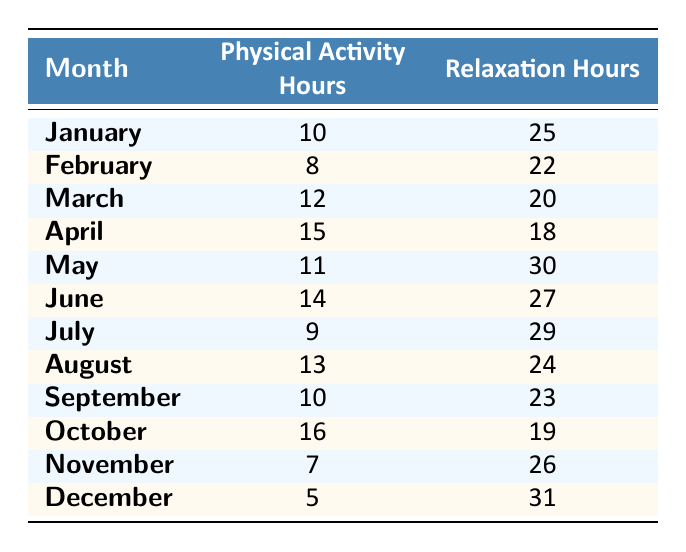What month had the highest physical activity hours? By examining the Physical Activity Hours column, April shows the highest value with 15 hours.
Answer: April What month had the lowest relaxation hours? Looking at the Relaxation Hours column, December has the lowest value with 31 hours.
Answer: December What is the total number of physical activity hours tracked in the first half of the year (January to June)? Summing the first six months: 10 (Jan) + 8 (Feb) + 12 (Mar) + 15 (Apr) + 11 (May) + 14 (Jun) = 70 hours.
Answer: 70 Was there more relaxation time than physical activity time in March? In March, there were 12 Physical Activity Hours and 20 Relaxation Hours, indicating relaxation hours exceeded physical activity hours.
Answer: Yes What is the average number of relaxation hours per month over the year? Adding all the Relaxation Hours: 25 + 22 + 20 + 18 + 30 + 27 + 29 + 24 + 23 + 19 + 26 + 31 =  24.5 and dividing by 12 (months) gives the average of 24.5 hours per month.
Answer: 24.5 Which month saw a significant drop in physical activity hours compared to the previous month? By looking at the differences, November has a significant drop with only 7 hours compared to 16 in October (a difference of 9 hours).
Answer: November How many more relaxation hours were recorded in May than in July? May had 30 Relaxation Hours and July had 29 hours, so the difference is 30 - 29 = 1 hour more in May.
Answer: 1 In which month did physical activity hours fall below 10? The data shows that both February (8) and November (7) had physical activity hours below 10.
Answer: February and November What was the total difference between the highest and lowest physical activity hours? The highest recorded was 16 in October and the lowest was 5 in December, so the total difference is 16 - 5 = 11 hours.
Answer: 11 